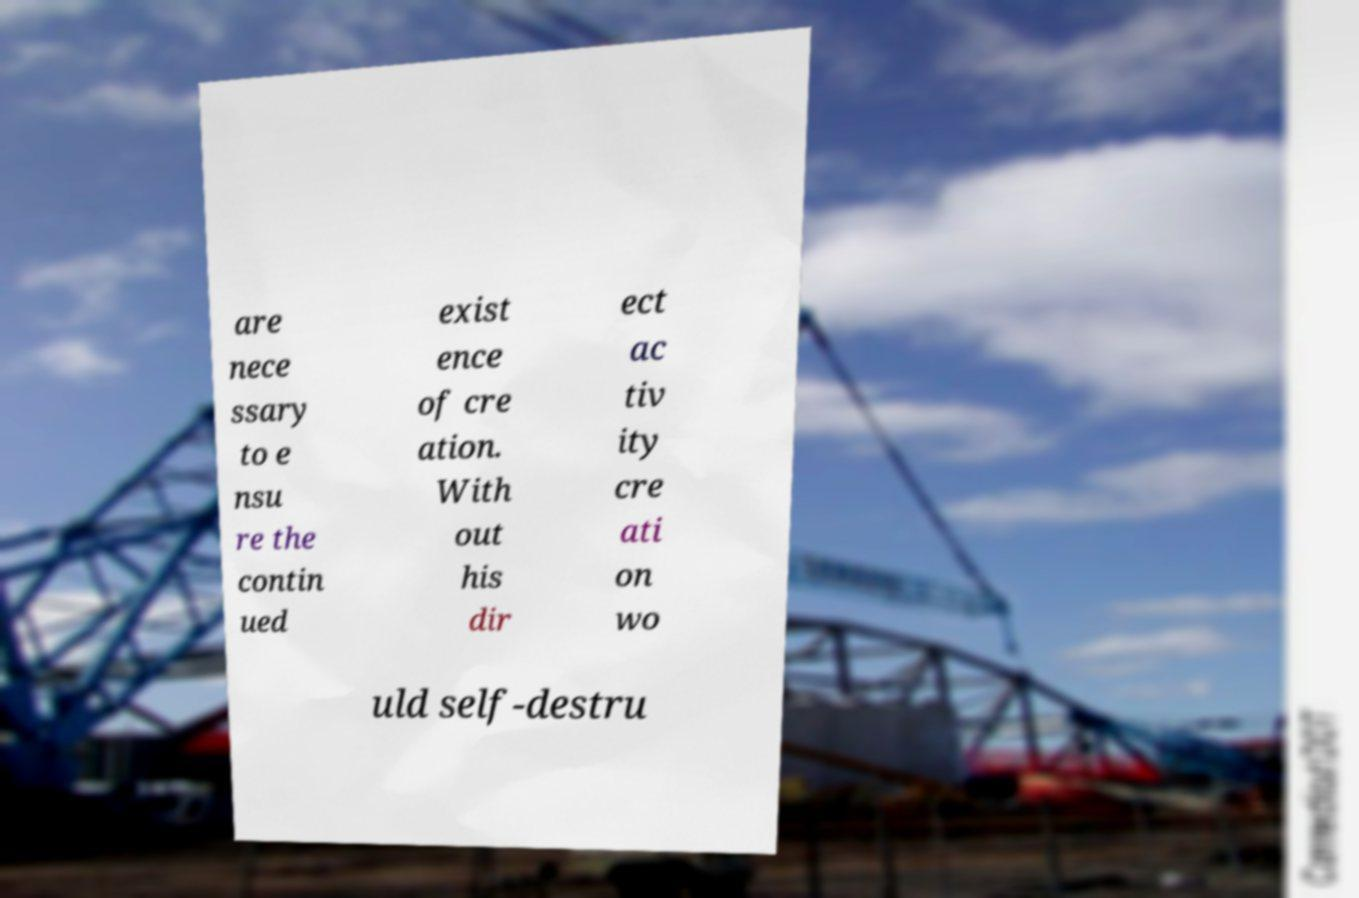Can you accurately transcribe the text from the provided image for me? are nece ssary to e nsu re the contin ued exist ence of cre ation. With out his dir ect ac tiv ity cre ati on wo uld self-destru 